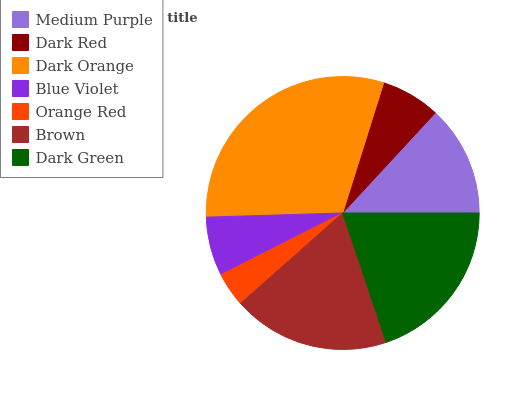Is Orange Red the minimum?
Answer yes or no. Yes. Is Dark Orange the maximum?
Answer yes or no. Yes. Is Dark Red the minimum?
Answer yes or no. No. Is Dark Red the maximum?
Answer yes or no. No. Is Medium Purple greater than Dark Red?
Answer yes or no. Yes. Is Dark Red less than Medium Purple?
Answer yes or no. Yes. Is Dark Red greater than Medium Purple?
Answer yes or no. No. Is Medium Purple less than Dark Red?
Answer yes or no. No. Is Medium Purple the high median?
Answer yes or no. Yes. Is Medium Purple the low median?
Answer yes or no. Yes. Is Blue Violet the high median?
Answer yes or no. No. Is Dark Red the low median?
Answer yes or no. No. 